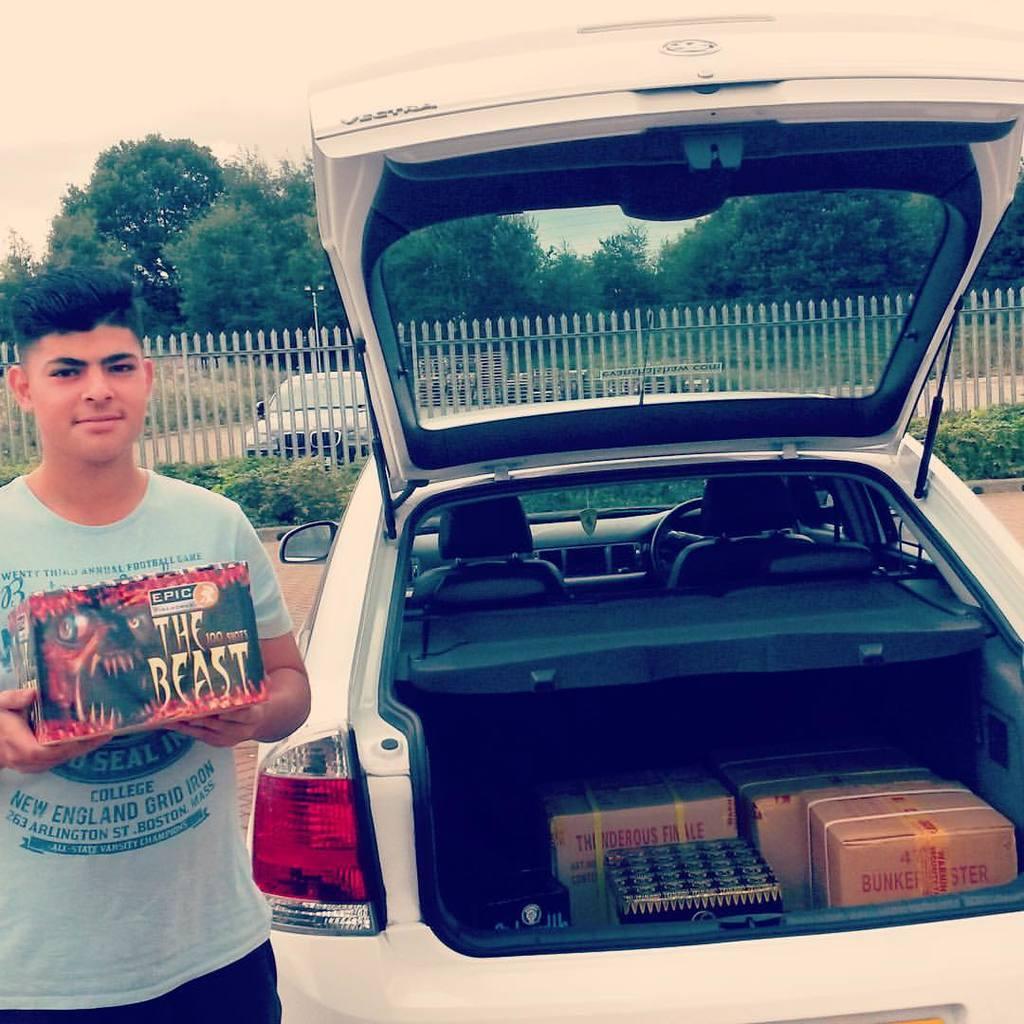Please provide a concise description of this image. In this image there is a vehicle with some objects in it, beside the vehicle there is a person standing and holding something in his hand, behind the person there are a few plants and a railing, behind the railing there is a vehicle parked. In the background there are trees and the sky. 